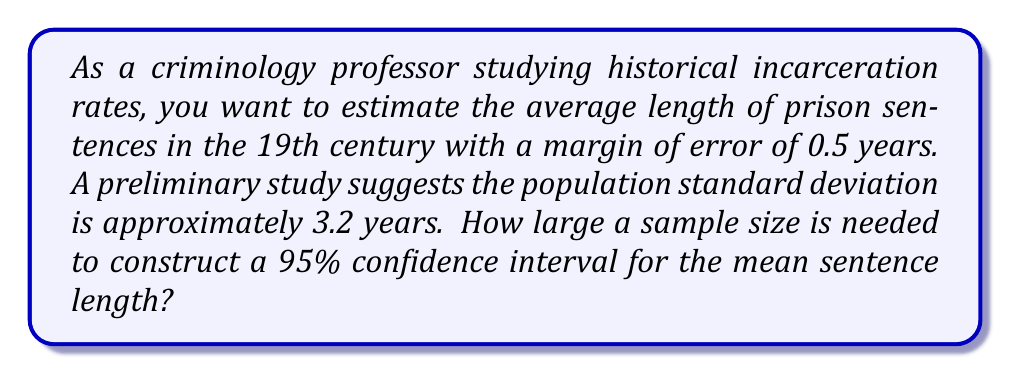Teach me how to tackle this problem. To determine the required sample size for a confidence interval, we'll use the formula:

$$n = \left(\frac{z_{\alpha/2} \cdot \sigma}{E}\right)^2$$

Where:
$n$ = sample size
$z_{\alpha/2}$ = z-score for the desired confidence level
$\sigma$ = population standard deviation
$E$ = margin of error

Step 1: Identify the known values
- Confidence level = 95%, so $z_{\alpha/2} = 1.96$
- $\sigma = 3.2$ years
- $E = 0.5$ years

Step 2: Plug the values into the formula
$$n = \left(\frac{1.96 \cdot 3.2}{0.5}\right)^2$$

Step 3: Calculate
$$n = (12.544)^2 = 157.35$$

Step 4: Round up to the nearest whole number
$n = 158$

Therefore, a sample size of 158 historical prison sentences is needed to construct a 95% confidence interval for the mean sentence length with a margin of error of 0.5 years.
Answer: 158 